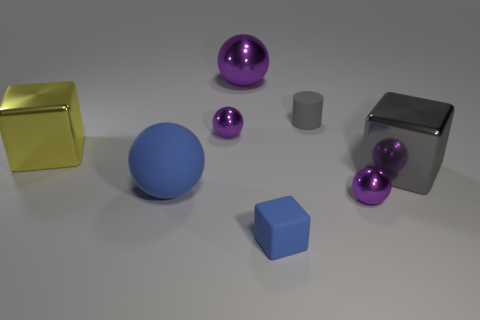Subtract all big blue matte balls. How many balls are left? 3 Subtract all blue balls. How many balls are left? 3 Add 1 gray cubes. How many objects exist? 9 Subtract 0 cyan blocks. How many objects are left? 8 Subtract all cubes. How many objects are left? 5 Subtract 1 cylinders. How many cylinders are left? 0 Subtract all brown cylinders. Subtract all red blocks. How many cylinders are left? 1 Subtract all blue cylinders. How many blue blocks are left? 1 Subtract all large yellow things. Subtract all blue shiny things. How many objects are left? 7 Add 8 large gray shiny objects. How many large gray shiny objects are left? 9 